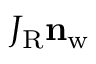Convert formula to latex. <formula><loc_0><loc_0><loc_500><loc_500>J _ { R } n _ { w }</formula> 